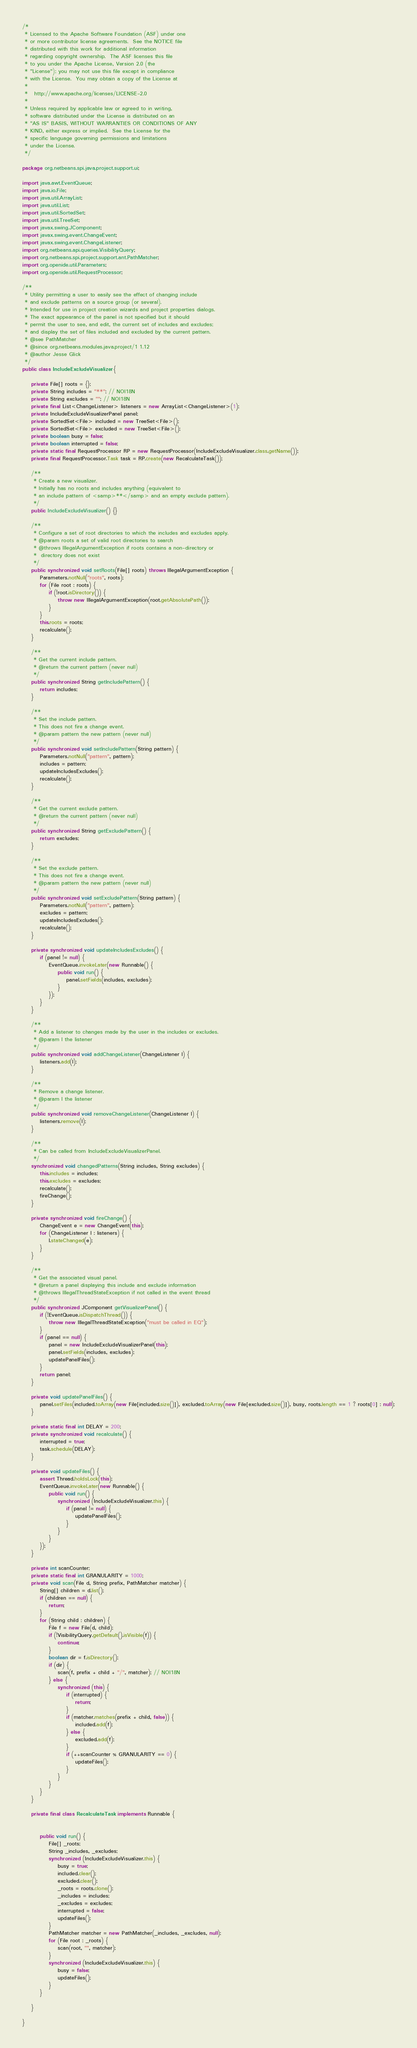<code> <loc_0><loc_0><loc_500><loc_500><_Java_>/*
 * Licensed to the Apache Software Foundation (ASF) under one
 * or more contributor license agreements.  See the NOTICE file
 * distributed with this work for additional information
 * regarding copyright ownership.  The ASF licenses this file
 * to you under the Apache License, Version 2.0 (the
 * "License"); you may not use this file except in compliance
 * with the License.  You may obtain a copy of the License at
 *
 *   http://www.apache.org/licenses/LICENSE-2.0
 *
 * Unless required by applicable law or agreed to in writing,
 * software distributed under the License is distributed on an
 * "AS IS" BASIS, WITHOUT WARRANTIES OR CONDITIONS OF ANY
 * KIND, either express or implied.  See the License for the
 * specific language governing permissions and limitations
 * under the License.
 */

package org.netbeans.spi.java.project.support.ui;

import java.awt.EventQueue;
import java.io.File;
import java.util.ArrayList;
import java.util.List;
import java.util.SortedSet;
import java.util.TreeSet;
import javax.swing.JComponent;
import javax.swing.event.ChangeEvent;
import javax.swing.event.ChangeListener;
import org.netbeans.api.queries.VisibilityQuery;
import org.netbeans.spi.project.support.ant.PathMatcher;
import org.openide.util.Parameters;
import org.openide.util.RequestProcessor;

/**
 * Utility permitting a user to easily see the effect of changing include
 * and exclude patterns on a source group (or several).
 * Intended for use in project creation wizards and project properties dialogs.
 * The exact appearance of the panel is not specified but it should
 * permit the user to see, and edit, the current set of includes and excludes;
 * and display the set of files included and excluded by the current pattern.
 * @see PathMatcher
 * @since org.netbeans.modules.java.project/1 1.12
 * @author Jesse Glick
 */
public class IncludeExcludeVisualizer {

    private File[] roots = {};
    private String includes = "**"; // NOI18N
    private String excludes = ""; // NOI18N
    private final List<ChangeListener> listeners = new ArrayList<ChangeListener>(1);
    private IncludeExcludeVisualizerPanel panel;
    private SortedSet<File> included = new TreeSet<File>();
    private SortedSet<File> excluded = new TreeSet<File>();
    private boolean busy = false;
    private boolean interrupted = false;
    private static final RequestProcessor RP = new RequestProcessor(IncludeExcludeVisualizer.class.getName());
    private final RequestProcessor.Task task = RP.create(new RecalculateTask());

    /**
     * Create a new visualizer.
     * Initially has no roots and includes anything (equivalent to
     * an include pattern of <samp>**</samp> and an empty exclude pattern).
     */
    public IncludeExcludeVisualizer() {}

    /**
     * Configure a set of root directories to which the includes and excludes apply.
     * @param roots a set of valid root directories to search
     * @throws IllegalArgumentException if roots contains a non-directory or 
     *  directory does not exist
     */
    public synchronized void setRoots(File[] roots) throws IllegalArgumentException {
        Parameters.notNull("roots", roots);
        for (File root : roots) {
            if (!root.isDirectory()) {
                throw new IllegalArgumentException(root.getAbsolutePath());
            }
        }
        this.roots = roots;
        recalculate();
    }

    /**
     * Get the current include pattern.
     * @return the current pattern (never null)
     */
    public synchronized String getIncludePattern() {
        return includes;
    }

    /**
     * Set the include pattern.
     * This does not fire a change event.
     * @param pattern the new pattern (never null)
     */
    public synchronized void setIncludePattern(String pattern) {
        Parameters.notNull("pattern", pattern);
        includes = pattern;
        updateIncludesExcludes();
        recalculate();
    }

    /**
     * Get the current exclude pattern.
     * @return the current pattern (never null)
     */
    public synchronized String getExcludePattern() {
        return excludes;
    }

    /**
     * Set the exclude pattern.
     * This does not fire a change event.
     * @param pattern the new pattern (never null)
     */
    public synchronized void setExcludePattern(String pattern) {
        Parameters.notNull("pattern", pattern);
        excludes = pattern;
        updateIncludesExcludes();
        recalculate();
    }

    private synchronized void updateIncludesExcludes() {
        if (panel != null) {
            EventQueue.invokeLater(new Runnable() {
                public void run() {
                    panel.setFields(includes, excludes);
                }
            });
        }
    }

    /**
     * Add a listener to changes made by the user in the includes or excludes.
     * @param l the listener
     */
    public synchronized void addChangeListener(ChangeListener l) {
        listeners.add(l);
    }

    /**
     * Remove a change listener.
     * @param l the listener
     */
    public synchronized void removeChangeListener(ChangeListener l) {
        listeners.remove(l);
    }

    /**
     * Can be called from IncludeExcludeVisualizerPanel.
     */
    synchronized void changedPatterns(String includes, String excludes) {
        this.includes = includes;
        this.excludes = excludes;
        recalculate();
        fireChange();
    }

    private synchronized void fireChange() {
        ChangeEvent e = new ChangeEvent(this);
        for (ChangeListener l : listeners) {
            l.stateChanged(e);
        }
    }

    /**
     * Get the associated visual panel.
     * @return a panel displaying this include and exclude information
     * @throws IllegalThreadStateException if not called in the event thread
     */
    public synchronized JComponent getVisualizerPanel() {
        if (!EventQueue.isDispatchThread()) {
            throw new IllegalThreadStateException("must be called in EQ");
        }
        if (panel == null) {
            panel = new IncludeExcludeVisualizerPanel(this);
            panel.setFields(includes, excludes);
            updatePanelFiles();
        }
        return panel;
    }

    private void updatePanelFiles() {
        panel.setFiles(included.toArray(new File[included.size()]), excluded.toArray(new File[excluded.size()]), busy, roots.length == 1 ? roots[0] : null);
    }

    private static final int DELAY = 200;
    private synchronized void recalculate() {
        interrupted = true;
        task.schedule(DELAY);
    }

    private void updateFiles() {
        assert Thread.holdsLock(this);
        EventQueue.invokeLater(new Runnable() {
            public void run() {
                synchronized (IncludeExcludeVisualizer.this) {
                    if (panel != null) {
                        updatePanelFiles();
                    }
                }
            }
        });
    }

    private int scanCounter;
    private static final int GRANULARITY = 1000;
    private void scan(File d, String prefix, PathMatcher matcher) {
        String[] children = d.list();
        if (children == null) {
            return;
        }
        for (String child : children) {
            File f = new File(d, child);
            if (!VisibilityQuery.getDefault().isVisible(f)) {
                continue;
            }
            boolean dir = f.isDirectory();
            if (dir) {
                scan(f, prefix + child + "/", matcher); // NOI18N
            } else {
                synchronized (this) {
                    if (interrupted) {
                        return;
                    }
                    if (matcher.matches(prefix + child, false)) {
                        included.add(f);
                    } else {
                        excluded.add(f);
                    }
                    if (++scanCounter % GRANULARITY == 0) {
                        updateFiles();
                    }
                }
            }
        }
    }

    private final class RecalculateTask implements Runnable {


        public void run() {
            File[] _roots;
            String _includes, _excludes;
            synchronized (IncludeExcludeVisualizer.this) {
                busy = true;
                included.clear();
                excluded.clear();
                _roots = roots.clone();
                _includes = includes;
                _excludes = excludes;
                interrupted = false;
                updateFiles();
            }
            PathMatcher matcher = new PathMatcher(_includes, _excludes, null);
            for (File root : _roots) {
                scan(root, "", matcher);
            }
            synchronized (IncludeExcludeVisualizer.this) {
                busy = false;
                updateFiles();
            }
        }

    }

}
</code> 